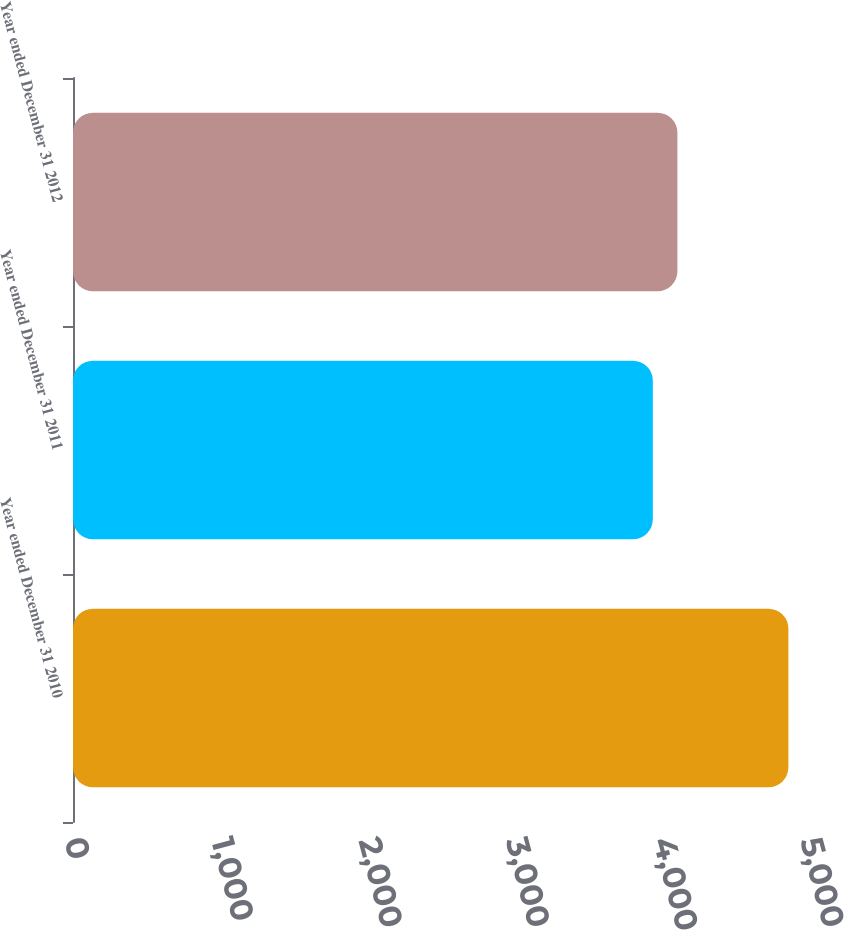Convert chart. <chart><loc_0><loc_0><loc_500><loc_500><bar_chart><fcel>Year ended December 31 2010<fcel>Year ended December 31 2011<fcel>Year ended December 31 2012<nl><fcel>4860<fcel>3939<fcel>4106<nl></chart> 